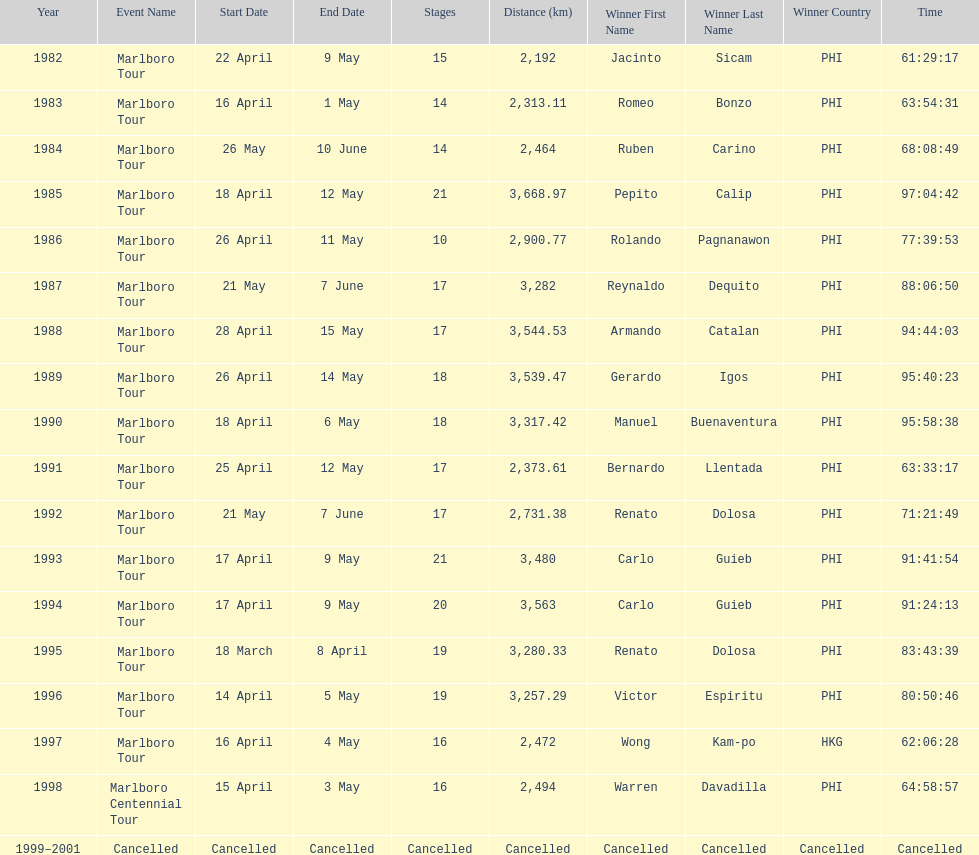Who won the most marlboro tours? Carlo Guieb. 